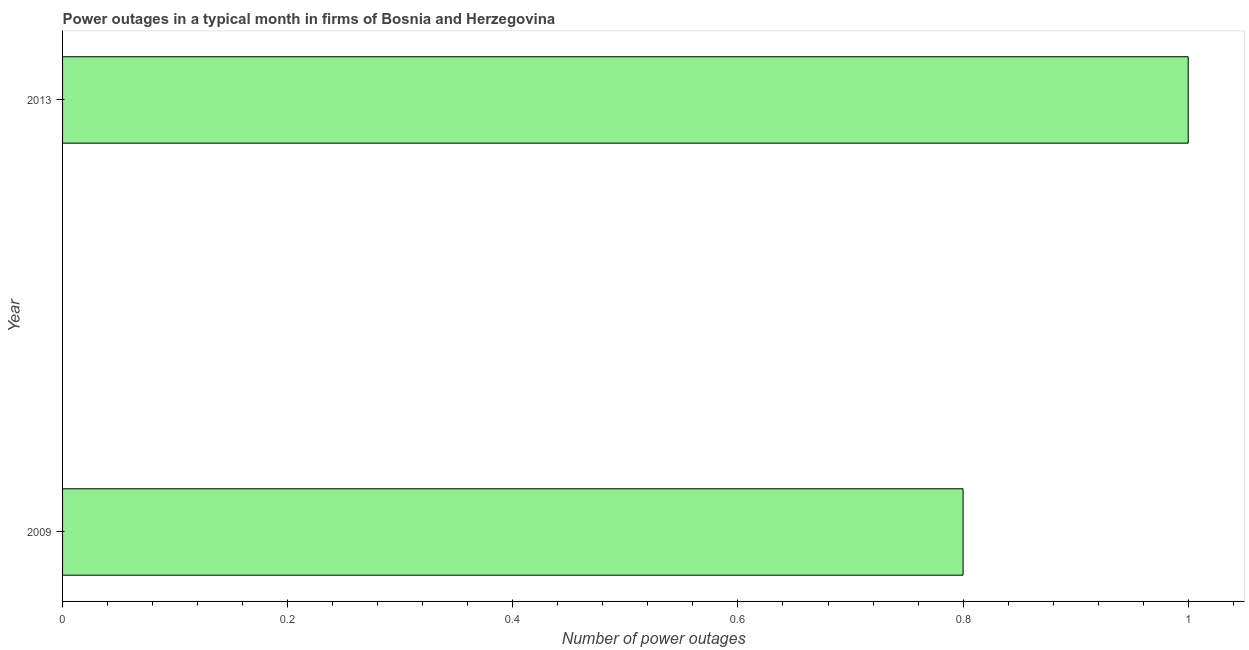What is the title of the graph?
Make the answer very short. Power outages in a typical month in firms of Bosnia and Herzegovina. What is the label or title of the X-axis?
Give a very brief answer. Number of power outages. What is the label or title of the Y-axis?
Provide a succinct answer. Year. Across all years, what is the maximum number of power outages?
Provide a short and direct response. 1. Across all years, what is the minimum number of power outages?
Your answer should be very brief. 0.8. In which year was the number of power outages maximum?
Provide a short and direct response. 2013. What is the sum of the number of power outages?
Your answer should be very brief. 1.8. What is the average number of power outages per year?
Your answer should be compact. 0.9. In how many years, is the number of power outages greater than the average number of power outages taken over all years?
Offer a very short reply. 1. How many bars are there?
Offer a terse response. 2. Are all the bars in the graph horizontal?
Your answer should be very brief. Yes. How many years are there in the graph?
Offer a very short reply. 2. What is the Number of power outages of 2009?
Your answer should be very brief. 0.8. What is the Number of power outages of 2013?
Your answer should be very brief. 1. What is the difference between the Number of power outages in 2009 and 2013?
Your answer should be very brief. -0.2. What is the ratio of the Number of power outages in 2009 to that in 2013?
Provide a succinct answer. 0.8. 